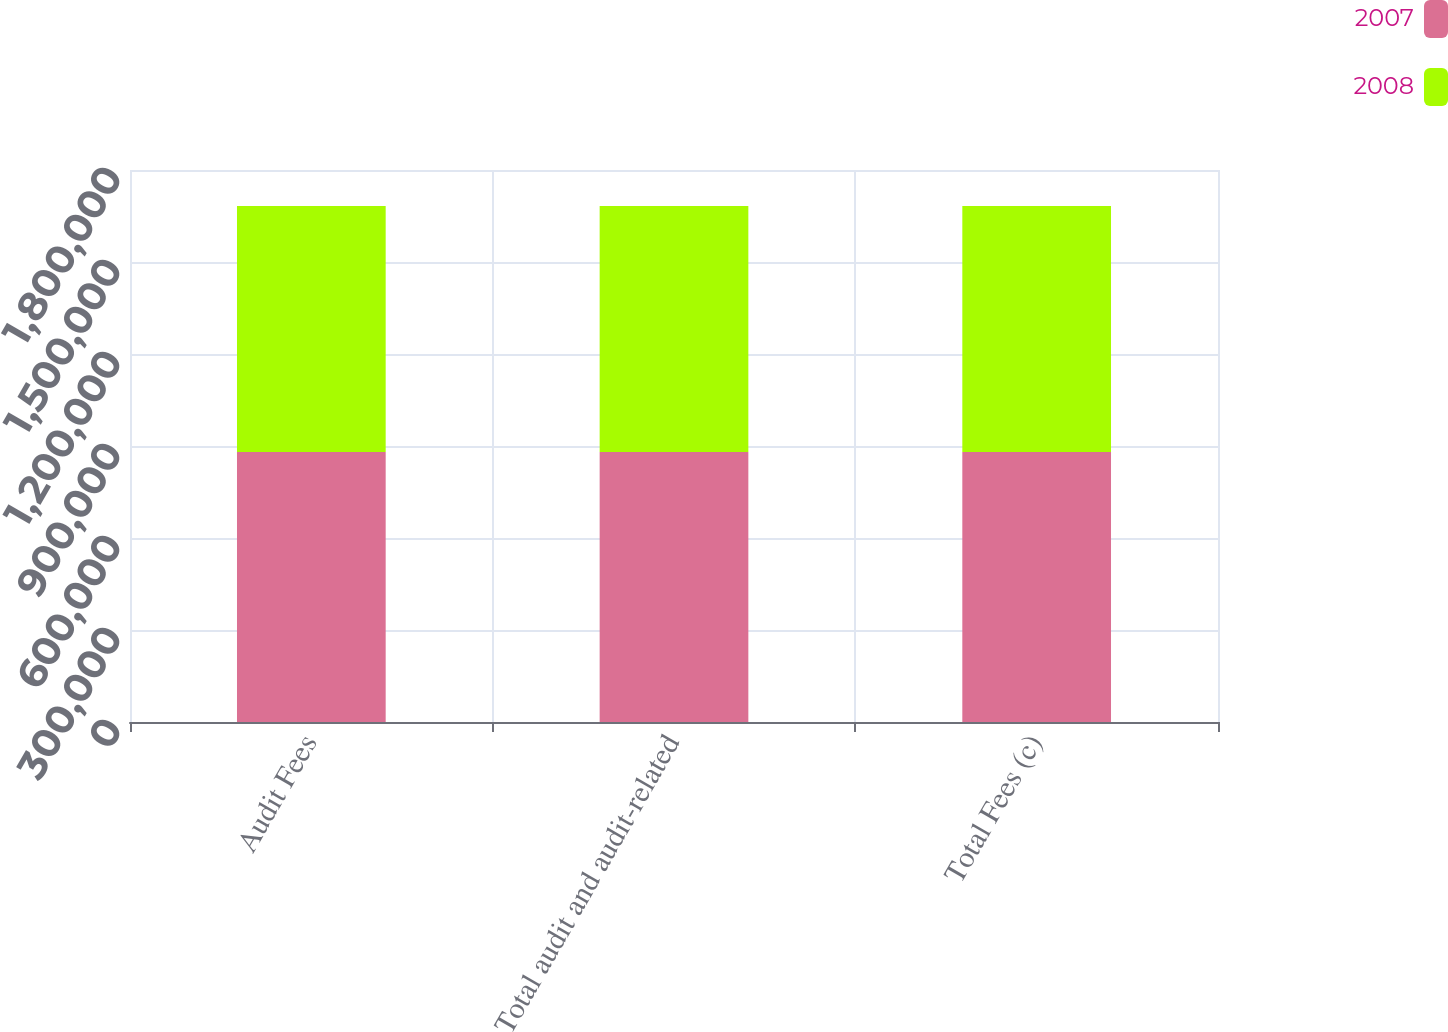<chart> <loc_0><loc_0><loc_500><loc_500><stacked_bar_chart><ecel><fcel>Audit Fees<fcel>Total audit and audit-related<fcel>Total Fees (c)<nl><fcel>2007<fcel>880674<fcel>880674<fcel>880674<nl><fcel>2008<fcel>801750<fcel>801750<fcel>801750<nl></chart> 